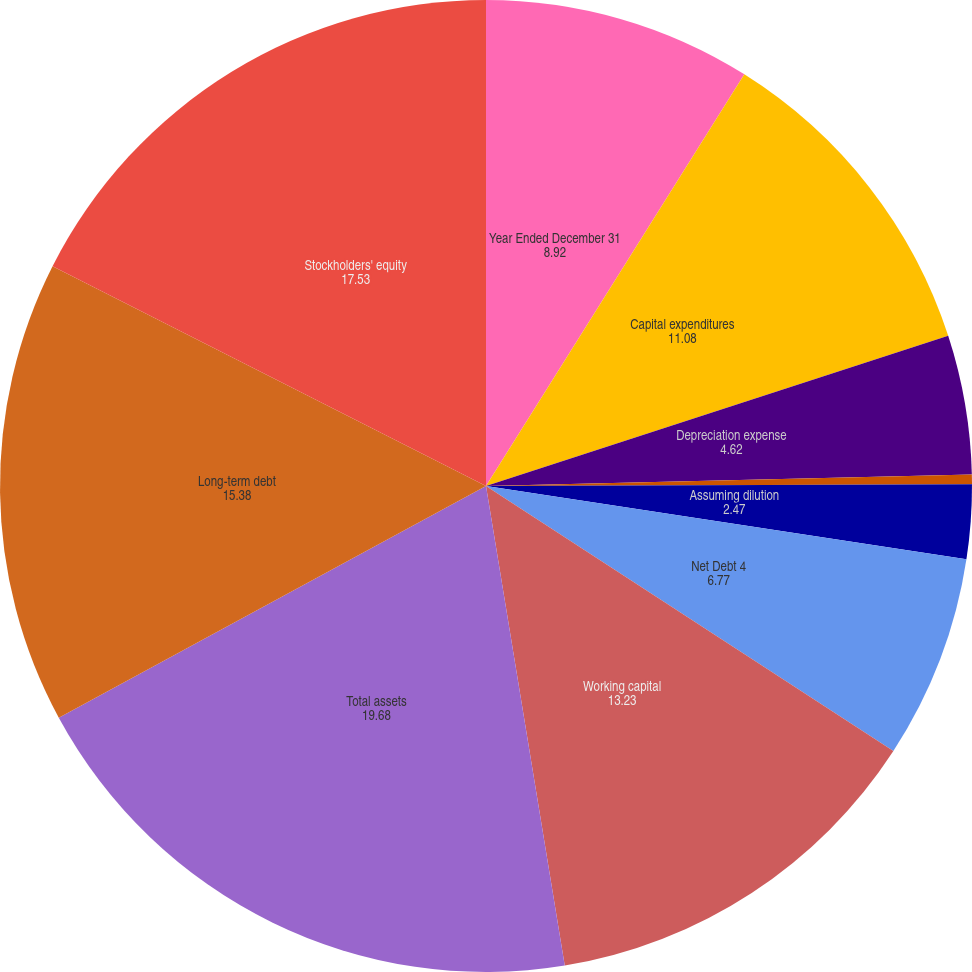<chart> <loc_0><loc_0><loc_500><loc_500><pie_chart><fcel>Year Ended December 31<fcel>Capital expenditures<fcel>Depreciation expense<fcel>Basic<fcel>Assuming dilution<fcel>Net Debt 4<fcel>Working capital<fcel>Total assets<fcel>Long-term debt<fcel>Stockholders' equity<nl><fcel>8.92%<fcel>11.08%<fcel>4.62%<fcel>0.32%<fcel>2.47%<fcel>6.77%<fcel>13.23%<fcel>19.68%<fcel>15.38%<fcel>17.53%<nl></chart> 